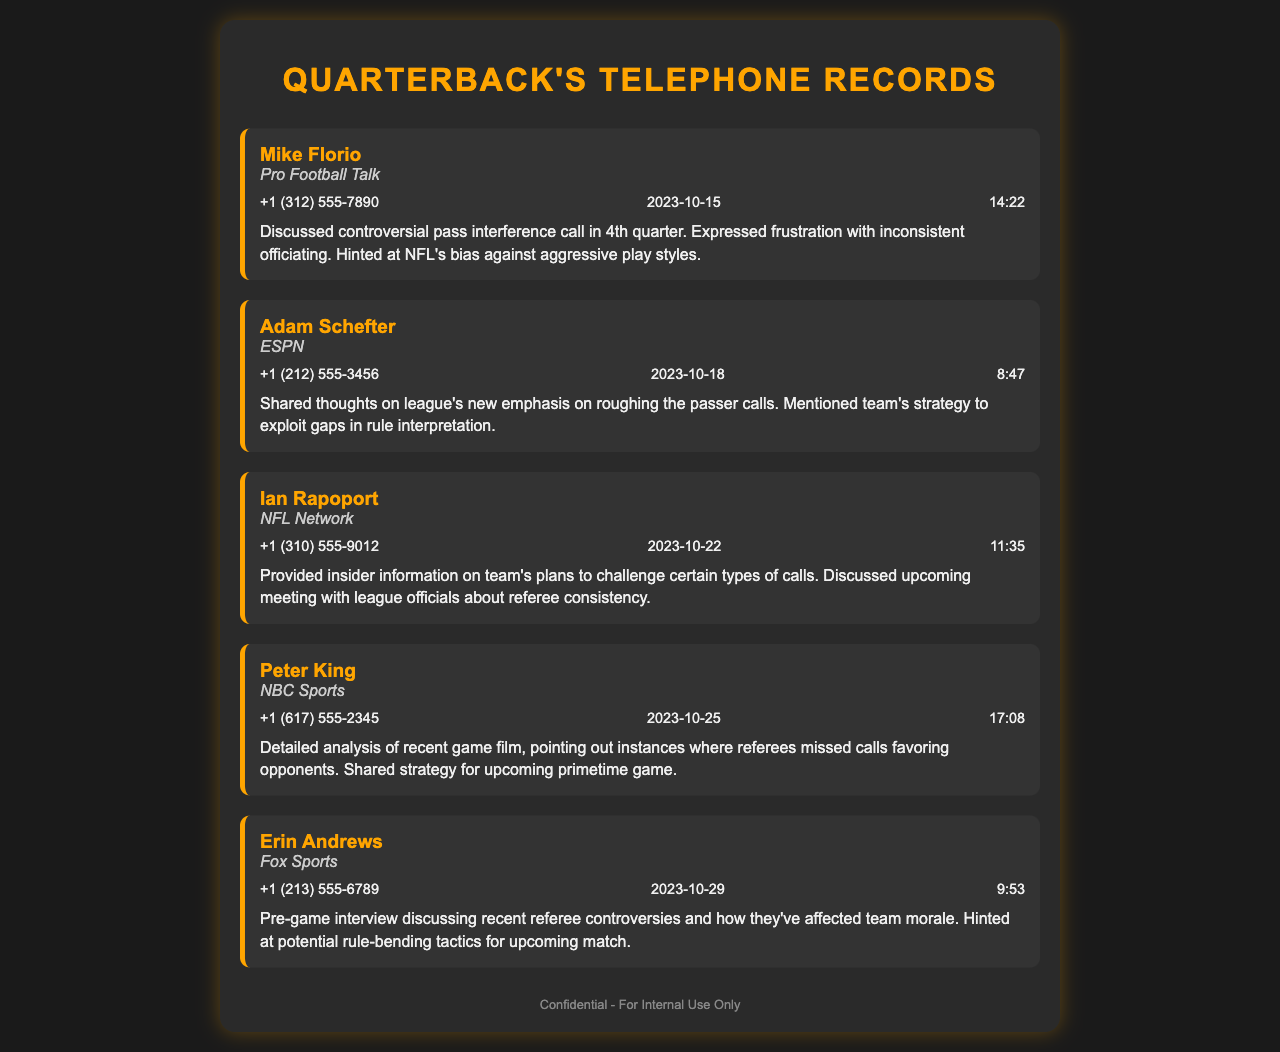what is the name of the first contact? The first contact listed in the document is Mike Florio.
Answer: Mike Florio what organization does Adam Schefter work for? The document states that Adam Schefter works for ESPN.
Answer: ESPN on what date did Erin Andrews have her call? The document indicates that Erin Andrews had her call on October 29, 2023.
Answer: 2023-10-29 what was discussed during the call with Ian Rapoport? The document summarizes that insider information on challenging certain calls and meeting with league officials about referee consistency was provided.
Answer: Challenging calls, referee consistency which call expressed frustration with officiating? The summary for the call with Mike Florio mentions frustration with inconsistent officiating.
Answer: Mike Florio how many contacts are mentioned in the document? The document outlines a total of five contacts.
Answer: Five what time was the call with Peter King? The call with Peter King took place at 17:08.
Answer: 17:08 which contact hinted at potential rule-bending tactics? The contact who hinted at potential rule-bending tactics is Erin Andrews.
Answer: Erin Andrews 